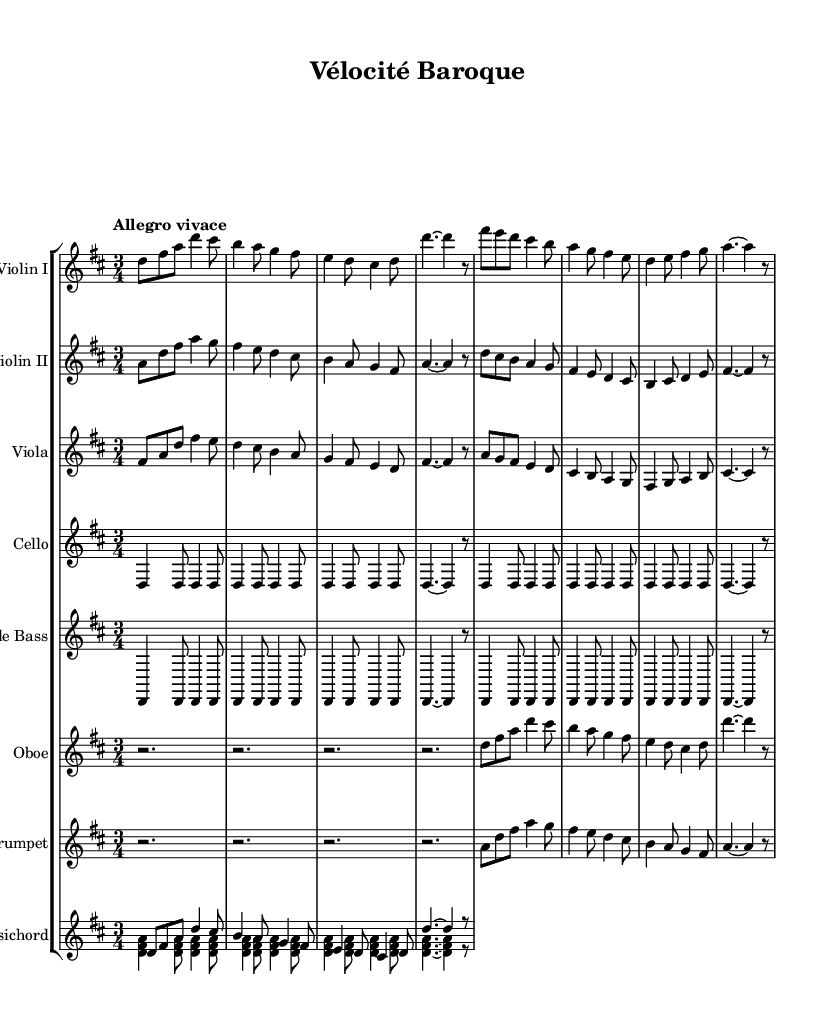What is the key signature of this music? The key signature is D major, which has two sharps (F# and C#). This is indicated at the beginning of the staff where the sharps are placed.
Answer: D major What is the time signature of this music? The time signature is 3/4, which is indicated at the beginning of the score. This means there are three beats per measure, and the quarter note gets one beat.
Answer: 3/4 What is the tempo marking for this piece? The tempo marking is "Allegro vivace," which indicates a fast and lively pace. It's placed at the beginning of the music to guide the performers on how quickly to play.
Answer: Allegro vivace How many measures does the Violin I section have? The Violin I section has eight measures. This can be counted by looking at the bar lines in the music, which separate the measures.
Answer: Eight Which instruments are featured in this orchestral suite? The instruments featured include Violin I, Violin II, Viola, Cello, Double Bass, Oboe, Trumpet, and Harpsichord. This is found in the score where each staff is labeled with the corresponding instrument's name.
Answer: Violin I, Violin II, Viola, Cello, Double Bass, Oboe, Trumpet, Harpsichord What is a characteristic feature of the rhythms in this Baroque suite? The characteristic feature of the rhythms in this Baroque suite is the energetic and lively patterns, often seen in the quick note values and the 3/4 time signature, which contribute to the fast-paced and upbeat nature typical of the Baroque style.
Answer: Energetic rhythms 